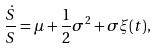<formula> <loc_0><loc_0><loc_500><loc_500>\frac { \dot { S } } { S } = \mu + \frac { 1 } { 2 } \sigma ^ { 2 } + \sigma \xi ( t ) ,</formula> 